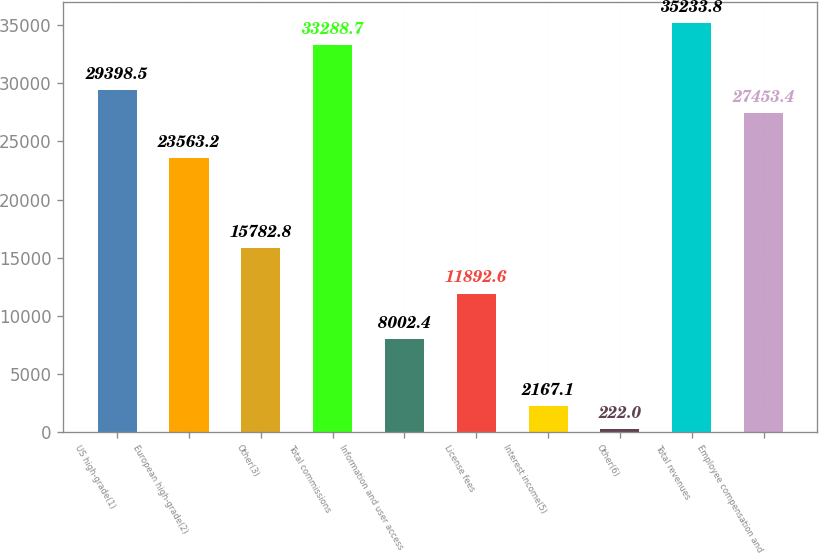<chart> <loc_0><loc_0><loc_500><loc_500><bar_chart><fcel>US high-grade(1)<fcel>European high-grade(2)<fcel>Other(3)<fcel>Total commissions<fcel>Information and user access<fcel>License fees<fcel>Interest income(5)<fcel>Other(6)<fcel>Total revenues<fcel>Employee compensation and<nl><fcel>29398.5<fcel>23563.2<fcel>15782.8<fcel>33288.7<fcel>8002.4<fcel>11892.6<fcel>2167.1<fcel>222<fcel>35233.8<fcel>27453.4<nl></chart> 